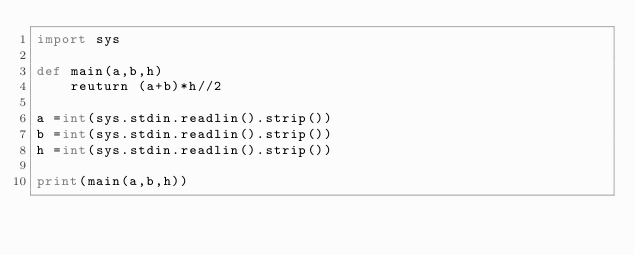<code> <loc_0><loc_0><loc_500><loc_500><_Python_>import sys

def main(a,b,h)
    reuturn (a+b)*h//2

a =int(sys.stdin.readlin().strip())
b =int(sys.stdin.readlin().strip())
h =int(sys.stdin.readlin().strip())

print(main(a,b,h))
</code> 